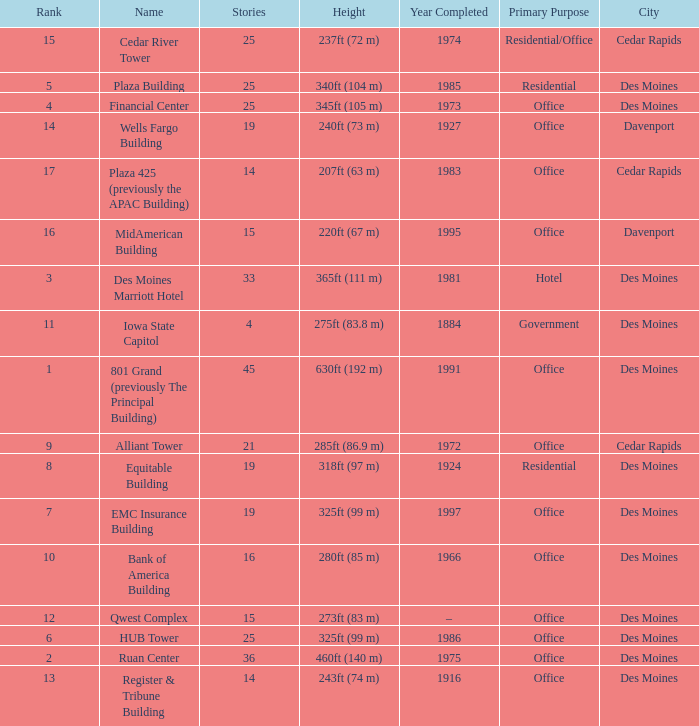Parse the full table. {'header': ['Rank', 'Name', 'Stories', 'Height', 'Year Completed', 'Primary Purpose', 'City'], 'rows': [['15', 'Cedar River Tower', '25', '237ft (72 m)', '1974', 'Residential/Office', 'Cedar Rapids'], ['5', 'Plaza Building', '25', '340ft (104 m)', '1985', 'Residential', 'Des Moines'], ['4', 'Financial Center', '25', '345ft (105 m)', '1973', 'Office', 'Des Moines'], ['14', 'Wells Fargo Building', '19', '240ft (73 m)', '1927', 'Office', 'Davenport'], ['17', 'Plaza 425 (previously the APAC Building)', '14', '207ft (63 m)', '1983', 'Office', 'Cedar Rapids'], ['16', 'MidAmerican Building', '15', '220ft (67 m)', '1995', 'Office', 'Davenport'], ['3', 'Des Moines Marriott Hotel', '33', '365ft (111 m)', '1981', 'Hotel', 'Des Moines'], ['11', 'Iowa State Capitol', '4', '275ft (83.8 m)', '1884', 'Government', 'Des Moines'], ['1', '801 Grand (previously The Principal Building)', '45', '630ft (192 m)', '1991', 'Office', 'Des Moines'], ['9', 'Alliant Tower', '21', '285ft (86.9 m)', '1972', 'Office', 'Cedar Rapids'], ['8', 'Equitable Building', '19', '318ft (97 m)', '1924', 'Residential', 'Des Moines'], ['7', 'EMC Insurance Building', '19', '325ft (99 m)', '1997', 'Office', 'Des Moines'], ['10', 'Bank of America Building', '16', '280ft (85 m)', '1966', 'Office', 'Des Moines'], ['12', 'Qwest Complex', '15', '273ft (83 m)', '–', 'Office', 'Des Moines'], ['6', 'HUB Tower', '25', '325ft (99 m)', '1986', 'Office', 'Des Moines'], ['2', 'Ruan Center', '36', '460ft (140 m)', '1975', 'Office', 'Des Moines'], ['13', 'Register & Tribune Building', '14', '243ft (74 m)', '1916', 'Office', 'Des Moines']]} What is the height of the EMC Insurance Building in Des Moines? 325ft (99 m). 